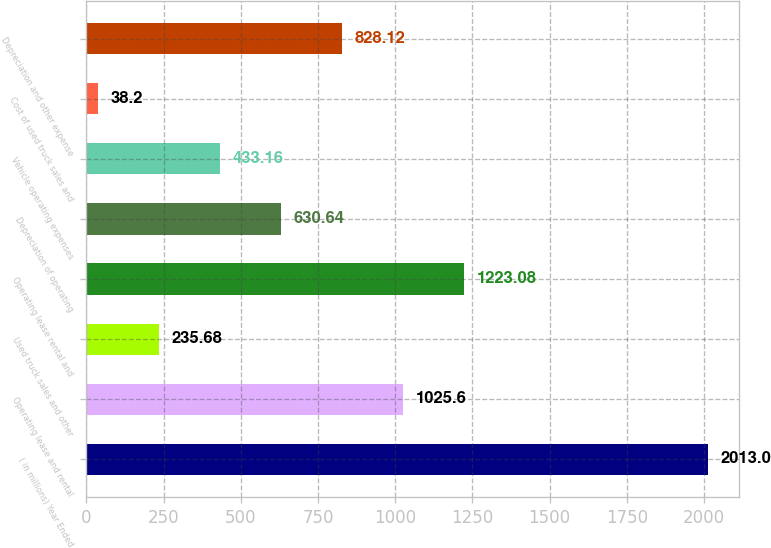Convert chart. <chart><loc_0><loc_0><loc_500><loc_500><bar_chart><fcel>( in millions) Year Ended<fcel>Operating lease and rental<fcel>Used truck sales and other<fcel>Operating lease rental and<fcel>Depreciation of operating<fcel>Vehicle operating expenses<fcel>Cost of used truck sales and<fcel>Depreciation and other expense<nl><fcel>2013<fcel>1025.6<fcel>235.68<fcel>1223.08<fcel>630.64<fcel>433.16<fcel>38.2<fcel>828.12<nl></chart> 